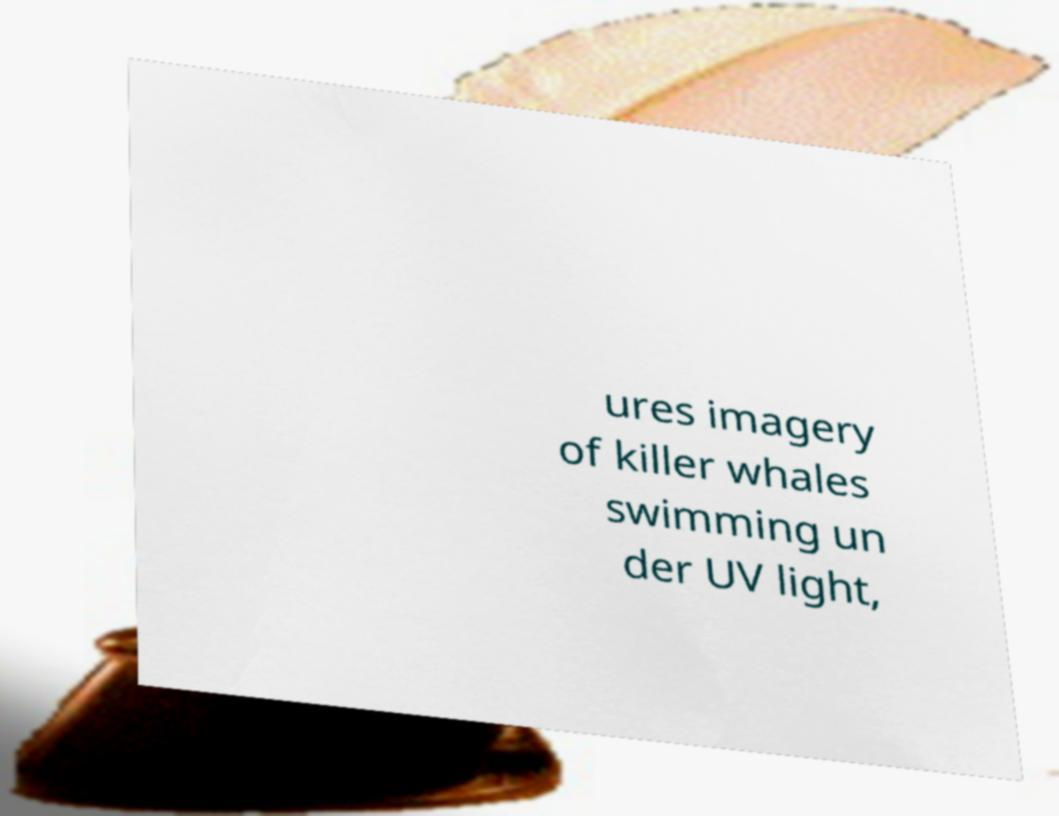Please read and relay the text visible in this image. What does it say? ures imagery of killer whales swimming un der UV light, 